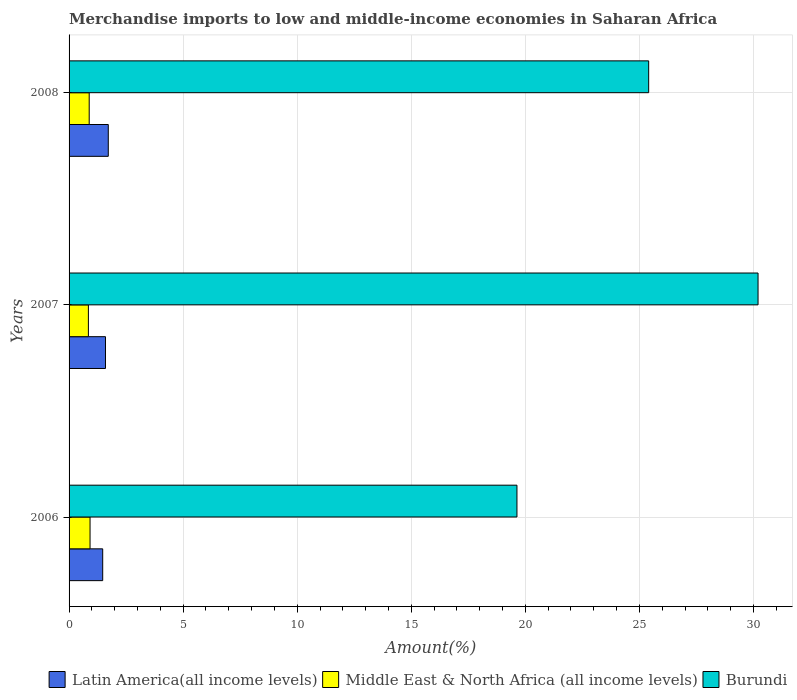How many different coloured bars are there?
Your response must be concise. 3. Are the number of bars per tick equal to the number of legend labels?
Offer a terse response. Yes. How many bars are there on the 3rd tick from the top?
Ensure brevity in your answer.  3. How many bars are there on the 1st tick from the bottom?
Your response must be concise. 3. What is the label of the 3rd group of bars from the top?
Provide a short and direct response. 2006. What is the percentage of amount earned from merchandise imports in Latin America(all income levels) in 2008?
Your response must be concise. 1.72. Across all years, what is the maximum percentage of amount earned from merchandise imports in Middle East & North Africa (all income levels)?
Your response must be concise. 0.92. Across all years, what is the minimum percentage of amount earned from merchandise imports in Latin America(all income levels)?
Offer a very short reply. 1.47. What is the total percentage of amount earned from merchandise imports in Middle East & North Africa (all income levels) in the graph?
Provide a short and direct response. 2.65. What is the difference between the percentage of amount earned from merchandise imports in Burundi in 2007 and that in 2008?
Make the answer very short. 4.79. What is the difference between the percentage of amount earned from merchandise imports in Latin America(all income levels) in 2006 and the percentage of amount earned from merchandise imports in Middle East & North Africa (all income levels) in 2007?
Ensure brevity in your answer.  0.63. What is the average percentage of amount earned from merchandise imports in Burundi per year?
Offer a terse response. 25.08. In the year 2006, what is the difference between the percentage of amount earned from merchandise imports in Latin America(all income levels) and percentage of amount earned from merchandise imports in Burundi?
Keep it short and to the point. -18.16. What is the ratio of the percentage of amount earned from merchandise imports in Latin America(all income levels) in 2007 to that in 2008?
Keep it short and to the point. 0.93. What is the difference between the highest and the second highest percentage of amount earned from merchandise imports in Burundi?
Your answer should be compact. 4.79. What is the difference between the highest and the lowest percentage of amount earned from merchandise imports in Burundi?
Make the answer very short. 10.57. In how many years, is the percentage of amount earned from merchandise imports in Latin America(all income levels) greater than the average percentage of amount earned from merchandise imports in Latin America(all income levels) taken over all years?
Your response must be concise. 1. Is the sum of the percentage of amount earned from merchandise imports in Latin America(all income levels) in 2007 and 2008 greater than the maximum percentage of amount earned from merchandise imports in Burundi across all years?
Provide a succinct answer. No. What does the 3rd bar from the top in 2006 represents?
Make the answer very short. Latin America(all income levels). What does the 3rd bar from the bottom in 2008 represents?
Make the answer very short. Burundi. Does the graph contain any zero values?
Provide a short and direct response. No. Does the graph contain grids?
Your response must be concise. Yes. How many legend labels are there?
Provide a succinct answer. 3. How are the legend labels stacked?
Keep it short and to the point. Horizontal. What is the title of the graph?
Give a very brief answer. Merchandise imports to low and middle-income economies in Saharan Africa. What is the label or title of the X-axis?
Your answer should be very brief. Amount(%). What is the label or title of the Y-axis?
Provide a succinct answer. Years. What is the Amount(%) of Latin America(all income levels) in 2006?
Your answer should be very brief. 1.47. What is the Amount(%) in Middle East & North Africa (all income levels) in 2006?
Your response must be concise. 0.92. What is the Amount(%) of Burundi in 2006?
Provide a succinct answer. 19.63. What is the Amount(%) in Latin America(all income levels) in 2007?
Provide a short and direct response. 1.6. What is the Amount(%) in Middle East & North Africa (all income levels) in 2007?
Make the answer very short. 0.85. What is the Amount(%) in Burundi in 2007?
Your response must be concise. 30.2. What is the Amount(%) of Latin America(all income levels) in 2008?
Your response must be concise. 1.72. What is the Amount(%) in Middle East & North Africa (all income levels) in 2008?
Offer a very short reply. 0.88. What is the Amount(%) in Burundi in 2008?
Make the answer very short. 25.41. Across all years, what is the maximum Amount(%) in Latin America(all income levels)?
Your answer should be very brief. 1.72. Across all years, what is the maximum Amount(%) in Middle East & North Africa (all income levels)?
Ensure brevity in your answer.  0.92. Across all years, what is the maximum Amount(%) in Burundi?
Ensure brevity in your answer.  30.2. Across all years, what is the minimum Amount(%) of Latin America(all income levels)?
Keep it short and to the point. 1.47. Across all years, what is the minimum Amount(%) of Middle East & North Africa (all income levels)?
Your answer should be compact. 0.85. Across all years, what is the minimum Amount(%) in Burundi?
Offer a terse response. 19.63. What is the total Amount(%) in Latin America(all income levels) in the graph?
Your response must be concise. 4.79. What is the total Amount(%) in Middle East & North Africa (all income levels) in the graph?
Ensure brevity in your answer.  2.65. What is the total Amount(%) of Burundi in the graph?
Give a very brief answer. 75.24. What is the difference between the Amount(%) of Latin America(all income levels) in 2006 and that in 2007?
Offer a very short reply. -0.12. What is the difference between the Amount(%) in Middle East & North Africa (all income levels) in 2006 and that in 2007?
Provide a short and direct response. 0.07. What is the difference between the Amount(%) in Burundi in 2006 and that in 2007?
Your answer should be compact. -10.57. What is the difference between the Amount(%) of Latin America(all income levels) in 2006 and that in 2008?
Provide a succinct answer. -0.24. What is the difference between the Amount(%) in Middle East & North Africa (all income levels) in 2006 and that in 2008?
Provide a succinct answer. 0.04. What is the difference between the Amount(%) of Burundi in 2006 and that in 2008?
Keep it short and to the point. -5.77. What is the difference between the Amount(%) in Latin America(all income levels) in 2007 and that in 2008?
Offer a terse response. -0.12. What is the difference between the Amount(%) of Middle East & North Africa (all income levels) in 2007 and that in 2008?
Give a very brief answer. -0.04. What is the difference between the Amount(%) in Burundi in 2007 and that in 2008?
Ensure brevity in your answer.  4.79. What is the difference between the Amount(%) in Latin America(all income levels) in 2006 and the Amount(%) in Middle East & North Africa (all income levels) in 2007?
Give a very brief answer. 0.63. What is the difference between the Amount(%) in Latin America(all income levels) in 2006 and the Amount(%) in Burundi in 2007?
Give a very brief answer. -28.73. What is the difference between the Amount(%) in Middle East & North Africa (all income levels) in 2006 and the Amount(%) in Burundi in 2007?
Provide a short and direct response. -29.28. What is the difference between the Amount(%) in Latin America(all income levels) in 2006 and the Amount(%) in Middle East & North Africa (all income levels) in 2008?
Keep it short and to the point. 0.59. What is the difference between the Amount(%) of Latin America(all income levels) in 2006 and the Amount(%) of Burundi in 2008?
Your answer should be compact. -23.93. What is the difference between the Amount(%) of Middle East & North Africa (all income levels) in 2006 and the Amount(%) of Burundi in 2008?
Offer a very short reply. -24.49. What is the difference between the Amount(%) of Latin America(all income levels) in 2007 and the Amount(%) of Middle East & North Africa (all income levels) in 2008?
Make the answer very short. 0.71. What is the difference between the Amount(%) in Latin America(all income levels) in 2007 and the Amount(%) in Burundi in 2008?
Provide a succinct answer. -23.81. What is the difference between the Amount(%) in Middle East & North Africa (all income levels) in 2007 and the Amount(%) in Burundi in 2008?
Your answer should be compact. -24.56. What is the average Amount(%) of Latin America(all income levels) per year?
Make the answer very short. 1.6. What is the average Amount(%) in Middle East & North Africa (all income levels) per year?
Make the answer very short. 0.88. What is the average Amount(%) of Burundi per year?
Make the answer very short. 25.08. In the year 2006, what is the difference between the Amount(%) in Latin America(all income levels) and Amount(%) in Middle East & North Africa (all income levels)?
Provide a short and direct response. 0.55. In the year 2006, what is the difference between the Amount(%) of Latin America(all income levels) and Amount(%) of Burundi?
Your response must be concise. -18.16. In the year 2006, what is the difference between the Amount(%) in Middle East & North Africa (all income levels) and Amount(%) in Burundi?
Ensure brevity in your answer.  -18.71. In the year 2007, what is the difference between the Amount(%) of Latin America(all income levels) and Amount(%) of Middle East & North Africa (all income levels)?
Offer a terse response. 0.75. In the year 2007, what is the difference between the Amount(%) of Latin America(all income levels) and Amount(%) of Burundi?
Offer a very short reply. -28.61. In the year 2007, what is the difference between the Amount(%) in Middle East & North Africa (all income levels) and Amount(%) in Burundi?
Ensure brevity in your answer.  -29.36. In the year 2008, what is the difference between the Amount(%) of Latin America(all income levels) and Amount(%) of Middle East & North Africa (all income levels)?
Your answer should be compact. 0.84. In the year 2008, what is the difference between the Amount(%) in Latin America(all income levels) and Amount(%) in Burundi?
Provide a short and direct response. -23.69. In the year 2008, what is the difference between the Amount(%) of Middle East & North Africa (all income levels) and Amount(%) of Burundi?
Provide a succinct answer. -24.52. What is the ratio of the Amount(%) in Latin America(all income levels) in 2006 to that in 2007?
Give a very brief answer. 0.92. What is the ratio of the Amount(%) in Middle East & North Africa (all income levels) in 2006 to that in 2007?
Provide a short and direct response. 1.09. What is the ratio of the Amount(%) of Burundi in 2006 to that in 2007?
Provide a succinct answer. 0.65. What is the ratio of the Amount(%) of Latin America(all income levels) in 2006 to that in 2008?
Your response must be concise. 0.86. What is the ratio of the Amount(%) of Middle East & North Africa (all income levels) in 2006 to that in 2008?
Provide a short and direct response. 1.04. What is the ratio of the Amount(%) of Burundi in 2006 to that in 2008?
Provide a short and direct response. 0.77. What is the ratio of the Amount(%) in Latin America(all income levels) in 2007 to that in 2008?
Make the answer very short. 0.93. What is the ratio of the Amount(%) in Middle East & North Africa (all income levels) in 2007 to that in 2008?
Your response must be concise. 0.96. What is the ratio of the Amount(%) in Burundi in 2007 to that in 2008?
Ensure brevity in your answer.  1.19. What is the difference between the highest and the second highest Amount(%) of Latin America(all income levels)?
Give a very brief answer. 0.12. What is the difference between the highest and the second highest Amount(%) in Middle East & North Africa (all income levels)?
Offer a very short reply. 0.04. What is the difference between the highest and the second highest Amount(%) of Burundi?
Make the answer very short. 4.79. What is the difference between the highest and the lowest Amount(%) of Latin America(all income levels)?
Your answer should be very brief. 0.24. What is the difference between the highest and the lowest Amount(%) in Middle East & North Africa (all income levels)?
Give a very brief answer. 0.07. What is the difference between the highest and the lowest Amount(%) of Burundi?
Make the answer very short. 10.57. 